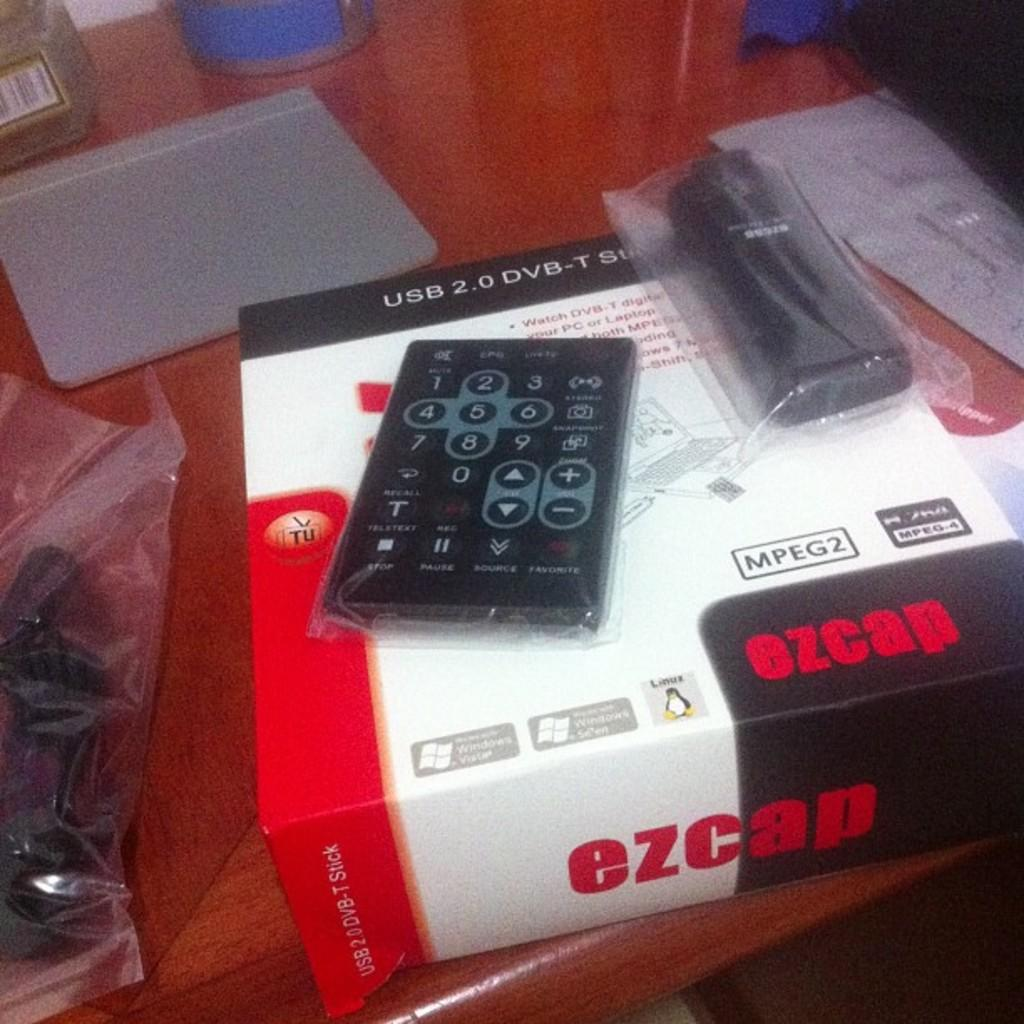<image>
Share a concise interpretation of the image provided. box for ezcap usb 2.0 dvb-t and remote and another item on top of the box 